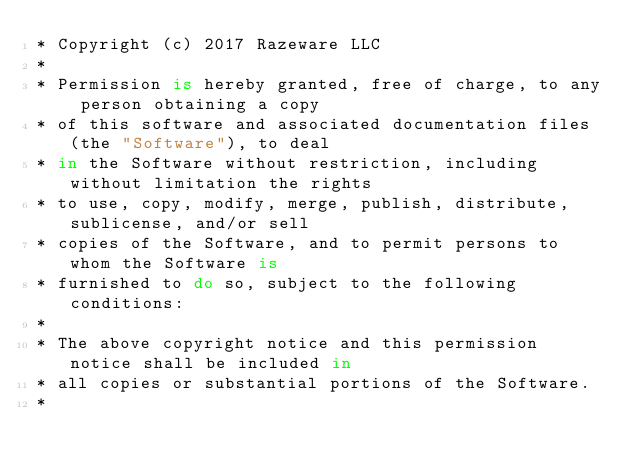<code> <loc_0><loc_0><loc_500><loc_500><_Swift_>* Copyright (c) 2017 Razeware LLC
*
* Permission is hereby granted, free of charge, to any person obtaining a copy
* of this software and associated documentation files (the "Software"), to deal
* in the Software without restriction, including without limitation the rights
* to use, copy, modify, merge, publish, distribute, sublicense, and/or sell
* copies of the Software, and to permit persons to whom the Software is
* furnished to do so, subject to the following conditions:
*
* The above copyright notice and this permission notice shall be included in
* all copies or substantial portions of the Software.
*</code> 